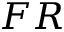<formula> <loc_0><loc_0><loc_500><loc_500>F R</formula> 